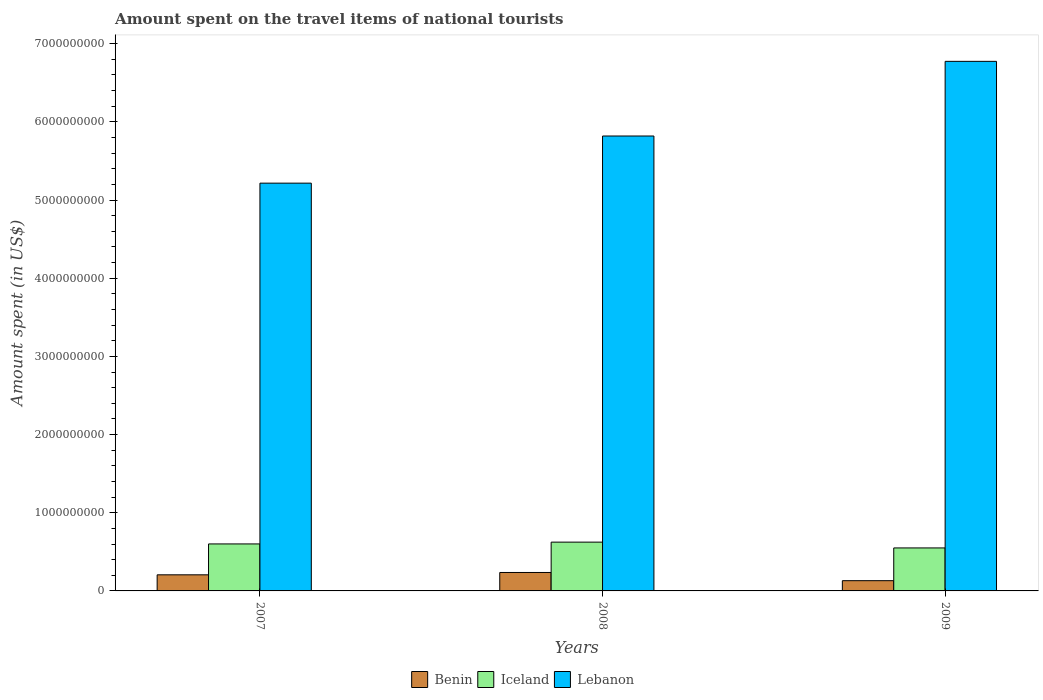How many groups of bars are there?
Offer a terse response. 3. Are the number of bars per tick equal to the number of legend labels?
Ensure brevity in your answer.  Yes. How many bars are there on the 3rd tick from the left?
Offer a very short reply. 3. In how many cases, is the number of bars for a given year not equal to the number of legend labels?
Make the answer very short. 0. What is the amount spent on the travel items of national tourists in Lebanon in 2008?
Make the answer very short. 5.82e+09. Across all years, what is the maximum amount spent on the travel items of national tourists in Benin?
Your response must be concise. 2.36e+08. Across all years, what is the minimum amount spent on the travel items of national tourists in Benin?
Make the answer very short. 1.31e+08. In which year was the amount spent on the travel items of national tourists in Benin minimum?
Your answer should be compact. 2009. What is the total amount spent on the travel items of national tourists in Lebanon in the graph?
Ensure brevity in your answer.  1.78e+1. What is the difference between the amount spent on the travel items of national tourists in Lebanon in 2007 and that in 2009?
Offer a very short reply. -1.56e+09. What is the difference between the amount spent on the travel items of national tourists in Iceland in 2007 and the amount spent on the travel items of national tourists in Benin in 2009?
Your answer should be very brief. 4.70e+08. What is the average amount spent on the travel items of national tourists in Lebanon per year?
Offer a very short reply. 5.94e+09. In the year 2008, what is the difference between the amount spent on the travel items of national tourists in Benin and amount spent on the travel items of national tourists in Iceland?
Make the answer very short. -3.88e+08. In how many years, is the amount spent on the travel items of national tourists in Benin greater than 400000000 US$?
Your response must be concise. 0. What is the ratio of the amount spent on the travel items of national tourists in Iceland in 2007 to that in 2008?
Give a very brief answer. 0.96. Is the amount spent on the travel items of national tourists in Lebanon in 2007 less than that in 2008?
Make the answer very short. Yes. What is the difference between the highest and the second highest amount spent on the travel items of national tourists in Iceland?
Ensure brevity in your answer.  2.30e+07. What is the difference between the highest and the lowest amount spent on the travel items of national tourists in Benin?
Give a very brief answer. 1.05e+08. Is the sum of the amount spent on the travel items of national tourists in Lebanon in 2007 and 2008 greater than the maximum amount spent on the travel items of national tourists in Iceland across all years?
Provide a short and direct response. Yes. How many bars are there?
Keep it short and to the point. 9. Are all the bars in the graph horizontal?
Your answer should be very brief. No. Does the graph contain any zero values?
Give a very brief answer. No. Does the graph contain grids?
Provide a succinct answer. No. What is the title of the graph?
Your response must be concise. Amount spent on the travel items of national tourists. What is the label or title of the Y-axis?
Ensure brevity in your answer.  Amount spent (in US$). What is the Amount spent (in US$) of Benin in 2007?
Provide a succinct answer. 2.06e+08. What is the Amount spent (in US$) in Iceland in 2007?
Keep it short and to the point. 6.01e+08. What is the Amount spent (in US$) in Lebanon in 2007?
Offer a terse response. 5.22e+09. What is the Amount spent (in US$) in Benin in 2008?
Make the answer very short. 2.36e+08. What is the Amount spent (in US$) of Iceland in 2008?
Give a very brief answer. 6.24e+08. What is the Amount spent (in US$) in Lebanon in 2008?
Make the answer very short. 5.82e+09. What is the Amount spent (in US$) of Benin in 2009?
Ensure brevity in your answer.  1.31e+08. What is the Amount spent (in US$) of Iceland in 2009?
Offer a terse response. 5.50e+08. What is the Amount spent (in US$) of Lebanon in 2009?
Your answer should be compact. 6.77e+09. Across all years, what is the maximum Amount spent (in US$) in Benin?
Your answer should be very brief. 2.36e+08. Across all years, what is the maximum Amount spent (in US$) of Iceland?
Keep it short and to the point. 6.24e+08. Across all years, what is the maximum Amount spent (in US$) of Lebanon?
Your answer should be very brief. 6.77e+09. Across all years, what is the minimum Amount spent (in US$) of Benin?
Make the answer very short. 1.31e+08. Across all years, what is the minimum Amount spent (in US$) in Iceland?
Your answer should be very brief. 5.50e+08. Across all years, what is the minimum Amount spent (in US$) of Lebanon?
Your response must be concise. 5.22e+09. What is the total Amount spent (in US$) in Benin in the graph?
Provide a short and direct response. 5.73e+08. What is the total Amount spent (in US$) of Iceland in the graph?
Your response must be concise. 1.78e+09. What is the total Amount spent (in US$) in Lebanon in the graph?
Give a very brief answer. 1.78e+1. What is the difference between the Amount spent (in US$) of Benin in 2007 and that in 2008?
Offer a very short reply. -3.00e+07. What is the difference between the Amount spent (in US$) of Iceland in 2007 and that in 2008?
Provide a succinct answer. -2.30e+07. What is the difference between the Amount spent (in US$) in Lebanon in 2007 and that in 2008?
Give a very brief answer. -6.03e+08. What is the difference between the Amount spent (in US$) of Benin in 2007 and that in 2009?
Provide a succinct answer. 7.50e+07. What is the difference between the Amount spent (in US$) of Iceland in 2007 and that in 2009?
Provide a succinct answer. 5.10e+07. What is the difference between the Amount spent (in US$) in Lebanon in 2007 and that in 2009?
Provide a short and direct response. -1.56e+09. What is the difference between the Amount spent (in US$) in Benin in 2008 and that in 2009?
Offer a terse response. 1.05e+08. What is the difference between the Amount spent (in US$) in Iceland in 2008 and that in 2009?
Offer a very short reply. 7.40e+07. What is the difference between the Amount spent (in US$) in Lebanon in 2008 and that in 2009?
Ensure brevity in your answer.  -9.55e+08. What is the difference between the Amount spent (in US$) in Benin in 2007 and the Amount spent (in US$) in Iceland in 2008?
Your response must be concise. -4.18e+08. What is the difference between the Amount spent (in US$) in Benin in 2007 and the Amount spent (in US$) in Lebanon in 2008?
Keep it short and to the point. -5.61e+09. What is the difference between the Amount spent (in US$) in Iceland in 2007 and the Amount spent (in US$) in Lebanon in 2008?
Offer a terse response. -5.22e+09. What is the difference between the Amount spent (in US$) of Benin in 2007 and the Amount spent (in US$) of Iceland in 2009?
Provide a succinct answer. -3.44e+08. What is the difference between the Amount spent (in US$) of Benin in 2007 and the Amount spent (in US$) of Lebanon in 2009?
Offer a terse response. -6.57e+09. What is the difference between the Amount spent (in US$) of Iceland in 2007 and the Amount spent (in US$) of Lebanon in 2009?
Provide a short and direct response. -6.17e+09. What is the difference between the Amount spent (in US$) of Benin in 2008 and the Amount spent (in US$) of Iceland in 2009?
Make the answer very short. -3.14e+08. What is the difference between the Amount spent (in US$) in Benin in 2008 and the Amount spent (in US$) in Lebanon in 2009?
Offer a very short reply. -6.54e+09. What is the difference between the Amount spent (in US$) of Iceland in 2008 and the Amount spent (in US$) of Lebanon in 2009?
Keep it short and to the point. -6.15e+09. What is the average Amount spent (in US$) in Benin per year?
Ensure brevity in your answer.  1.91e+08. What is the average Amount spent (in US$) in Iceland per year?
Give a very brief answer. 5.92e+08. What is the average Amount spent (in US$) of Lebanon per year?
Your answer should be very brief. 5.94e+09. In the year 2007, what is the difference between the Amount spent (in US$) in Benin and Amount spent (in US$) in Iceland?
Make the answer very short. -3.95e+08. In the year 2007, what is the difference between the Amount spent (in US$) of Benin and Amount spent (in US$) of Lebanon?
Ensure brevity in your answer.  -5.01e+09. In the year 2007, what is the difference between the Amount spent (in US$) of Iceland and Amount spent (in US$) of Lebanon?
Provide a succinct answer. -4.62e+09. In the year 2008, what is the difference between the Amount spent (in US$) in Benin and Amount spent (in US$) in Iceland?
Make the answer very short. -3.88e+08. In the year 2008, what is the difference between the Amount spent (in US$) in Benin and Amount spent (in US$) in Lebanon?
Your answer should be very brief. -5.58e+09. In the year 2008, what is the difference between the Amount spent (in US$) of Iceland and Amount spent (in US$) of Lebanon?
Offer a terse response. -5.20e+09. In the year 2009, what is the difference between the Amount spent (in US$) in Benin and Amount spent (in US$) in Iceland?
Offer a terse response. -4.19e+08. In the year 2009, what is the difference between the Amount spent (in US$) in Benin and Amount spent (in US$) in Lebanon?
Ensure brevity in your answer.  -6.64e+09. In the year 2009, what is the difference between the Amount spent (in US$) in Iceland and Amount spent (in US$) in Lebanon?
Your answer should be compact. -6.22e+09. What is the ratio of the Amount spent (in US$) of Benin in 2007 to that in 2008?
Ensure brevity in your answer.  0.87. What is the ratio of the Amount spent (in US$) of Iceland in 2007 to that in 2008?
Your answer should be very brief. 0.96. What is the ratio of the Amount spent (in US$) of Lebanon in 2007 to that in 2008?
Offer a very short reply. 0.9. What is the ratio of the Amount spent (in US$) of Benin in 2007 to that in 2009?
Your answer should be very brief. 1.57. What is the ratio of the Amount spent (in US$) of Iceland in 2007 to that in 2009?
Your answer should be compact. 1.09. What is the ratio of the Amount spent (in US$) of Lebanon in 2007 to that in 2009?
Provide a short and direct response. 0.77. What is the ratio of the Amount spent (in US$) in Benin in 2008 to that in 2009?
Make the answer very short. 1.8. What is the ratio of the Amount spent (in US$) of Iceland in 2008 to that in 2009?
Your response must be concise. 1.13. What is the ratio of the Amount spent (in US$) of Lebanon in 2008 to that in 2009?
Offer a terse response. 0.86. What is the difference between the highest and the second highest Amount spent (in US$) in Benin?
Your answer should be compact. 3.00e+07. What is the difference between the highest and the second highest Amount spent (in US$) of Iceland?
Provide a succinct answer. 2.30e+07. What is the difference between the highest and the second highest Amount spent (in US$) of Lebanon?
Provide a succinct answer. 9.55e+08. What is the difference between the highest and the lowest Amount spent (in US$) in Benin?
Make the answer very short. 1.05e+08. What is the difference between the highest and the lowest Amount spent (in US$) in Iceland?
Your answer should be very brief. 7.40e+07. What is the difference between the highest and the lowest Amount spent (in US$) in Lebanon?
Ensure brevity in your answer.  1.56e+09. 